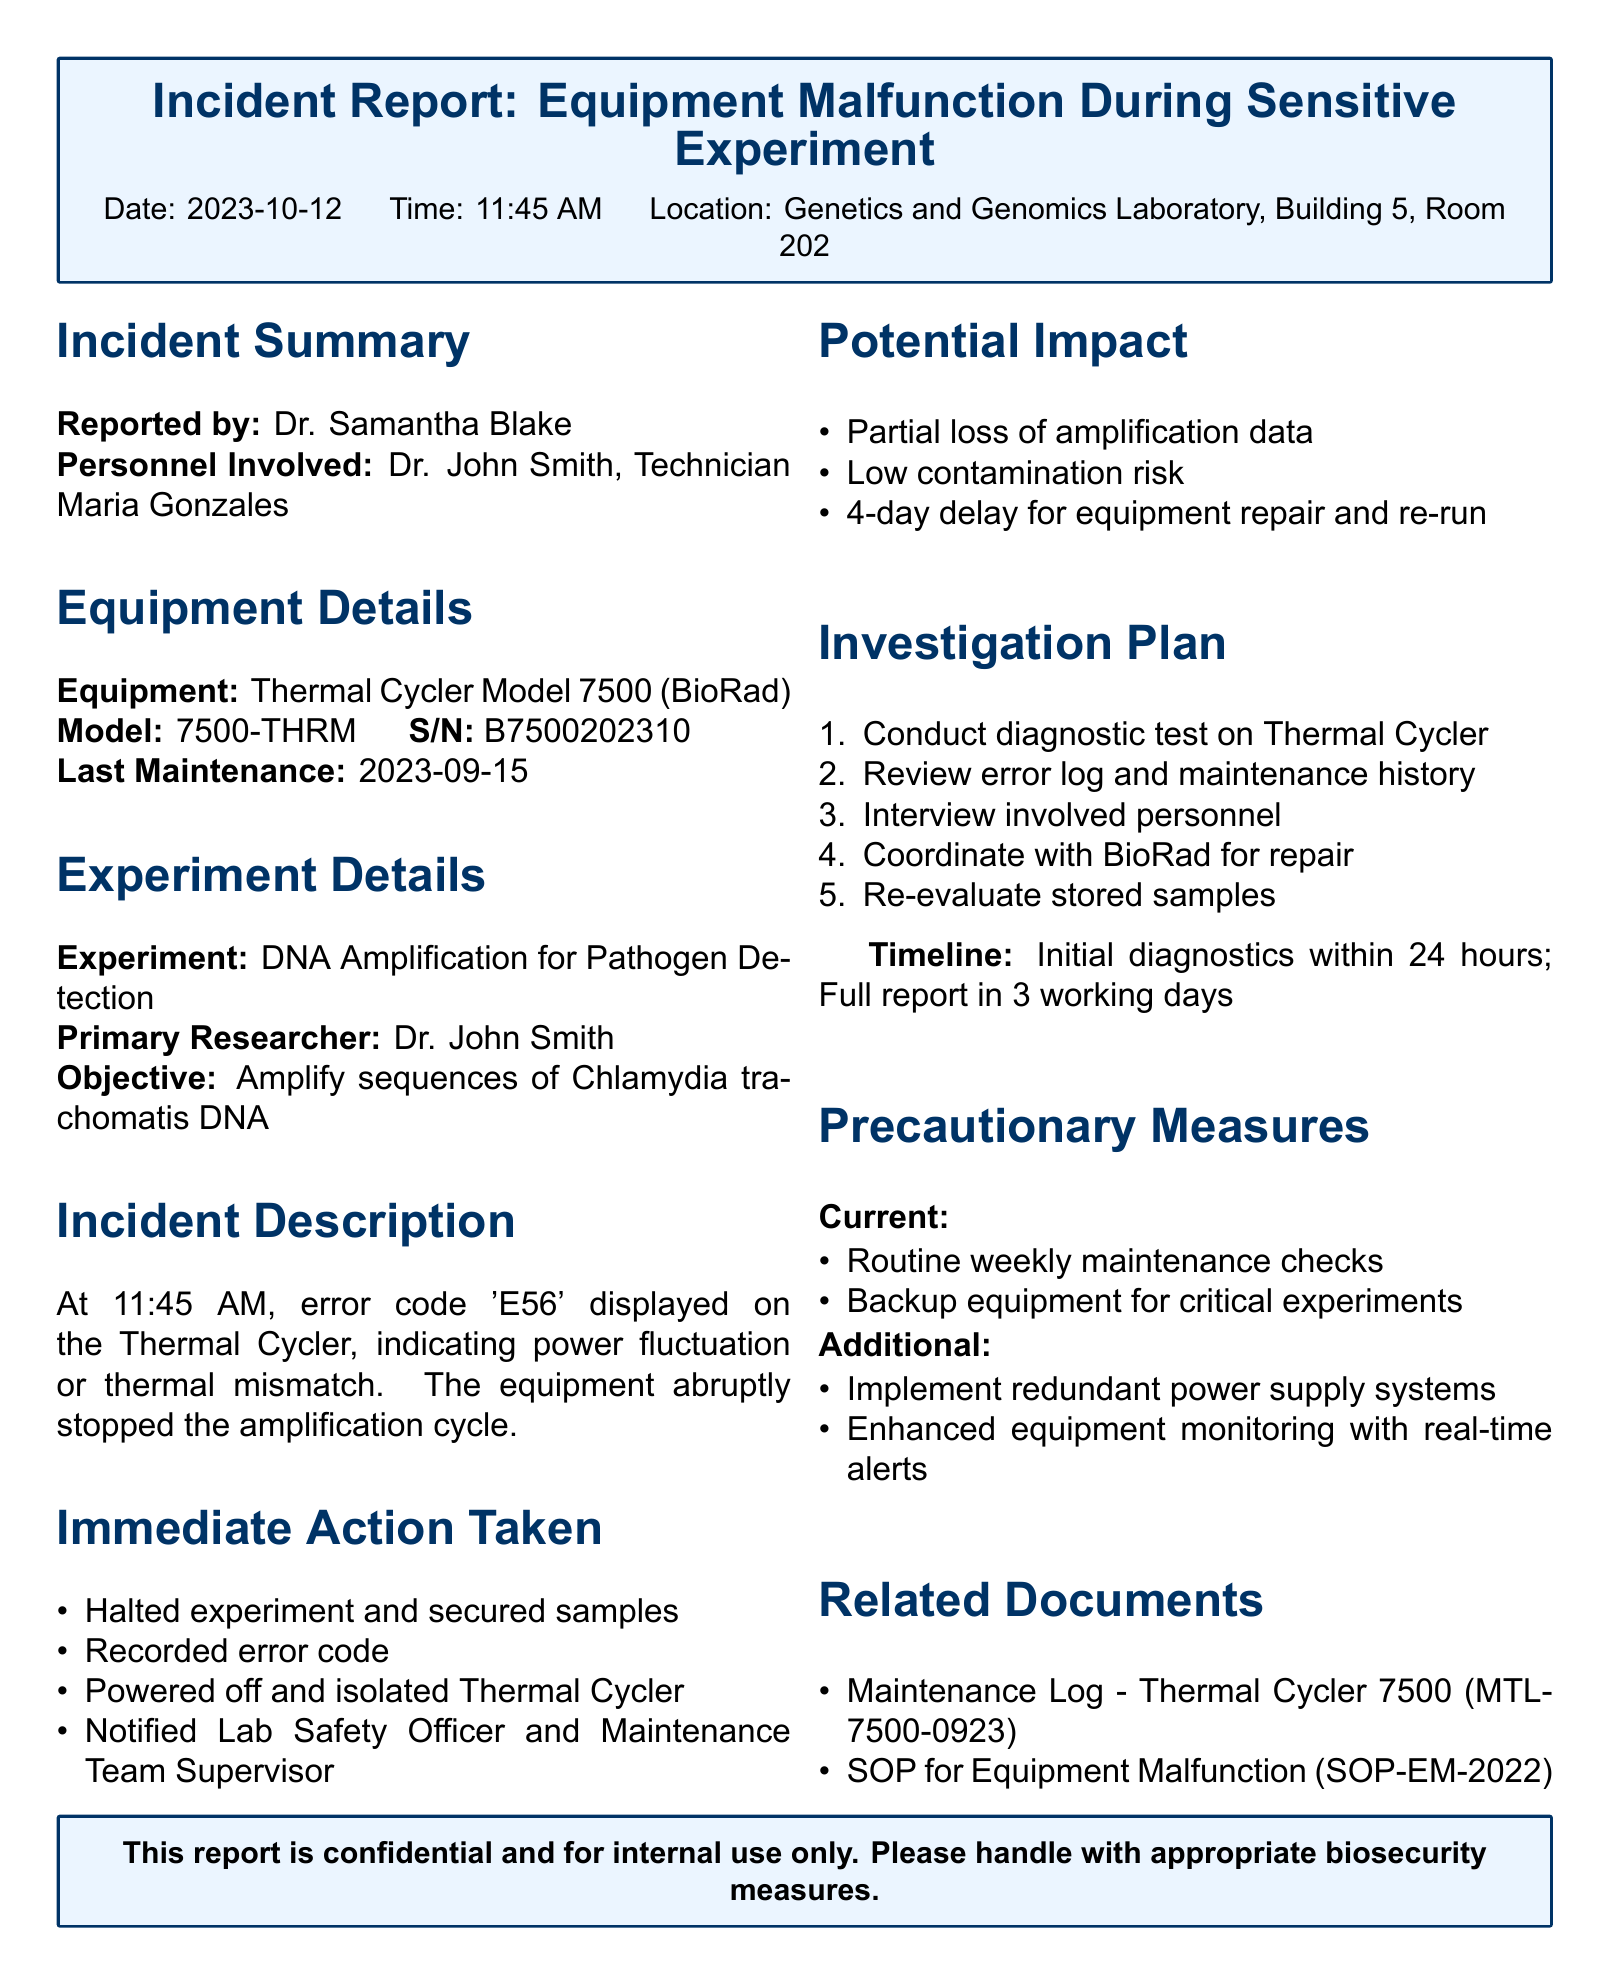What is the date of the incident? The date of the incident is specified in the report header section.
Answer: 2023-10-12 Who reported the incident? The name of the individual who reported the incident is included in the summary section.
Answer: Dr. Samantha Blake What specific error code was displayed on the Thermal Cycler? The error code is mentioned in the incident description section of the report.
Answer: E56 What is the potential impact regarding data loss? The document states the potential consequences related to data loss in the impact section.
Answer: Partial loss of amplification data How long is the estimated delay for equipment repair? The estimated delay for repair is given under the potential impact section of the report.
Answer: 4-day delay What is a precautionary measure already in place? The document lists existing precautionary measures in the precautionary measures section.
Answer: Routine weekly maintenance checks What action was taken immediately after the incident? The immediate actions taken after the malfunction are detailed in the immediate action taken section.
Answer: Halted experiment and secured samples What is the model of the affected equipment? The equipment model is mentioned in the equipment details section of the report.
Answer: 7500-THRM What is the location of the incident? The specific location where the incident occurred is indicated at the top of the report.
Answer: Genetics and Genomics Laboratory, Building 5, Room 202 